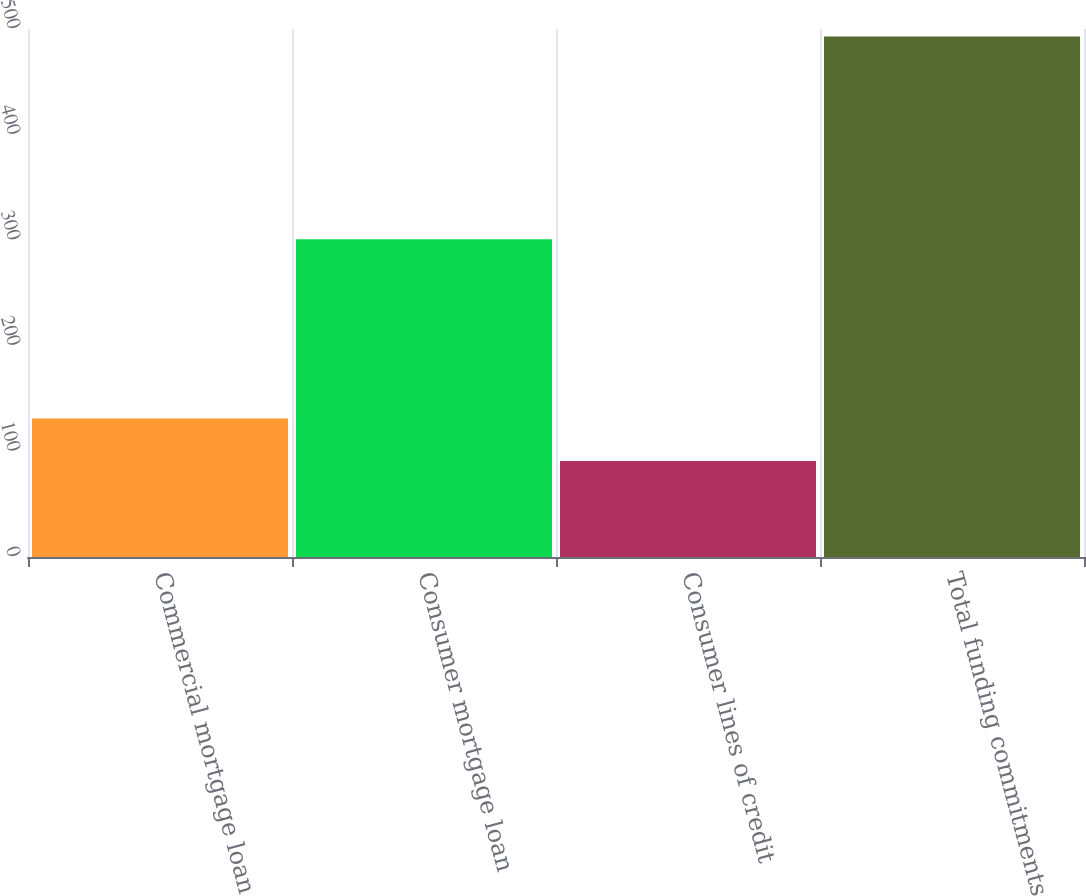Convert chart. <chart><loc_0><loc_0><loc_500><loc_500><bar_chart><fcel>Commercial mortgage loan<fcel>Consumer mortgage loan<fcel>Consumer lines of credit<fcel>Total funding commitments<nl><fcel>131.2<fcel>301<fcel>91<fcel>493<nl></chart> 